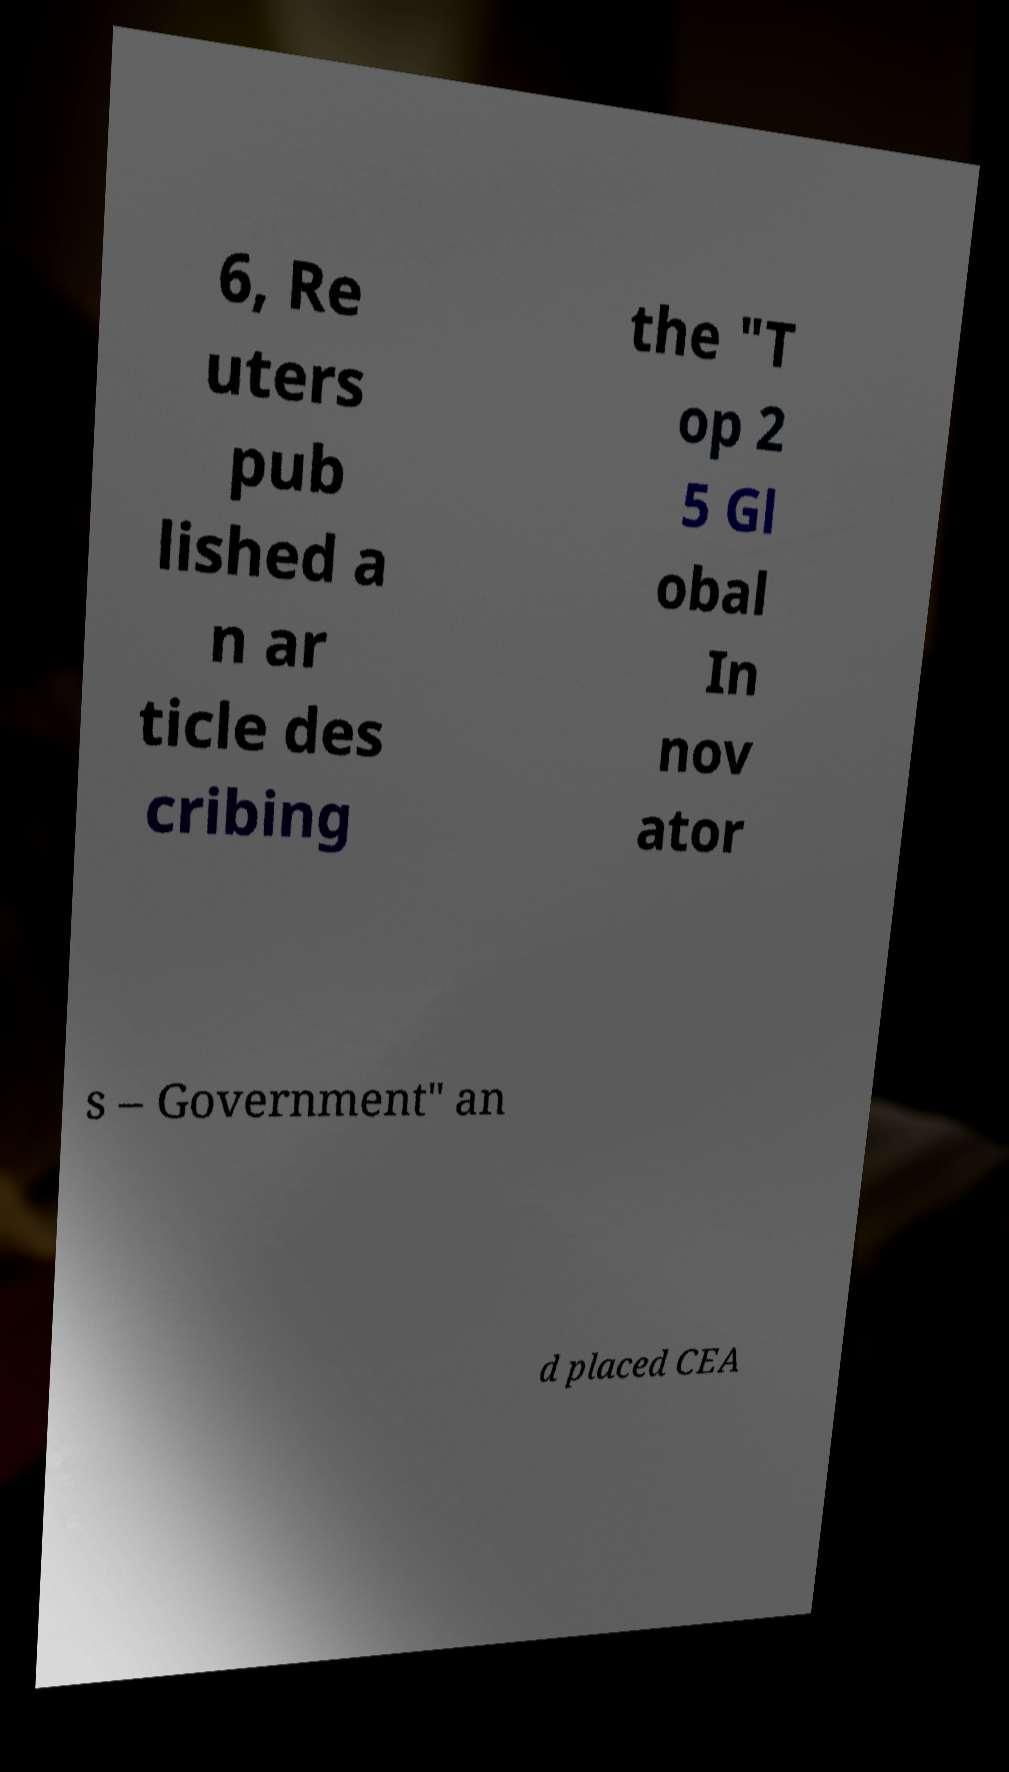I need the written content from this picture converted into text. Can you do that? 6, Re uters pub lished a n ar ticle des cribing the "T op 2 5 Gl obal In nov ator s – Government" an d placed CEA 